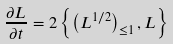<formula> <loc_0><loc_0><loc_500><loc_500>\frac { \partial L } { \partial t } = 2 \left \{ \left ( L ^ { { 1 } / { 2 } } \right ) _ { \leq 1 } , L \right \}</formula> 